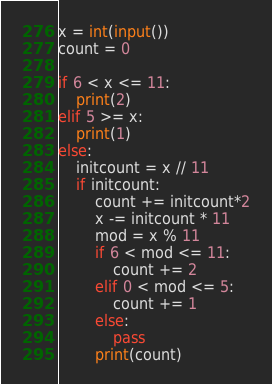Convert code to text. <code><loc_0><loc_0><loc_500><loc_500><_Python_>x = int(input())
count = 0

if 6 < x <= 11:
	print(2)
elif 5 >= x:
	print(1)
else:
	initcount = x // 11
	if initcount:
		count += initcount*2
		x -= initcount * 11
		mod = x % 11
		if 6 < mod <= 11:
			count += 2
		elif 0 < mod <= 5:
			count += 1
		else:
			pass
		print(count)
</code> 